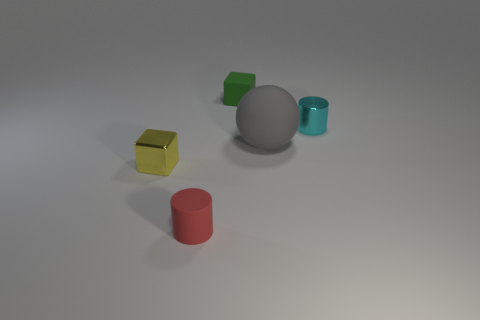Is there a rubber block that has the same size as the red object?
Give a very brief answer. Yes. There is a red cylinder that is the same size as the cyan metal cylinder; what is its material?
Your answer should be very brief. Rubber. How many green cylinders are there?
Offer a very short reply. 0. How big is the matte object that is behind the tiny cyan thing?
Your answer should be very brief. Small. Are there an equal number of tiny yellow cubes that are on the right side of the small red cylinder and big gray metallic spheres?
Your answer should be very brief. Yes. Is there a gray rubber object that has the same shape as the red object?
Provide a short and direct response. No. There is a rubber thing that is both in front of the rubber cube and right of the matte cylinder; what shape is it?
Give a very brief answer. Sphere. Is the gray thing made of the same material as the tiny cylinder to the right of the big rubber thing?
Ensure brevity in your answer.  No. Are there any shiny things on the right side of the tiny cyan cylinder?
Offer a very short reply. No. What number of things are either big purple shiny cylinders or tiny blocks that are in front of the rubber sphere?
Provide a short and direct response. 1. 